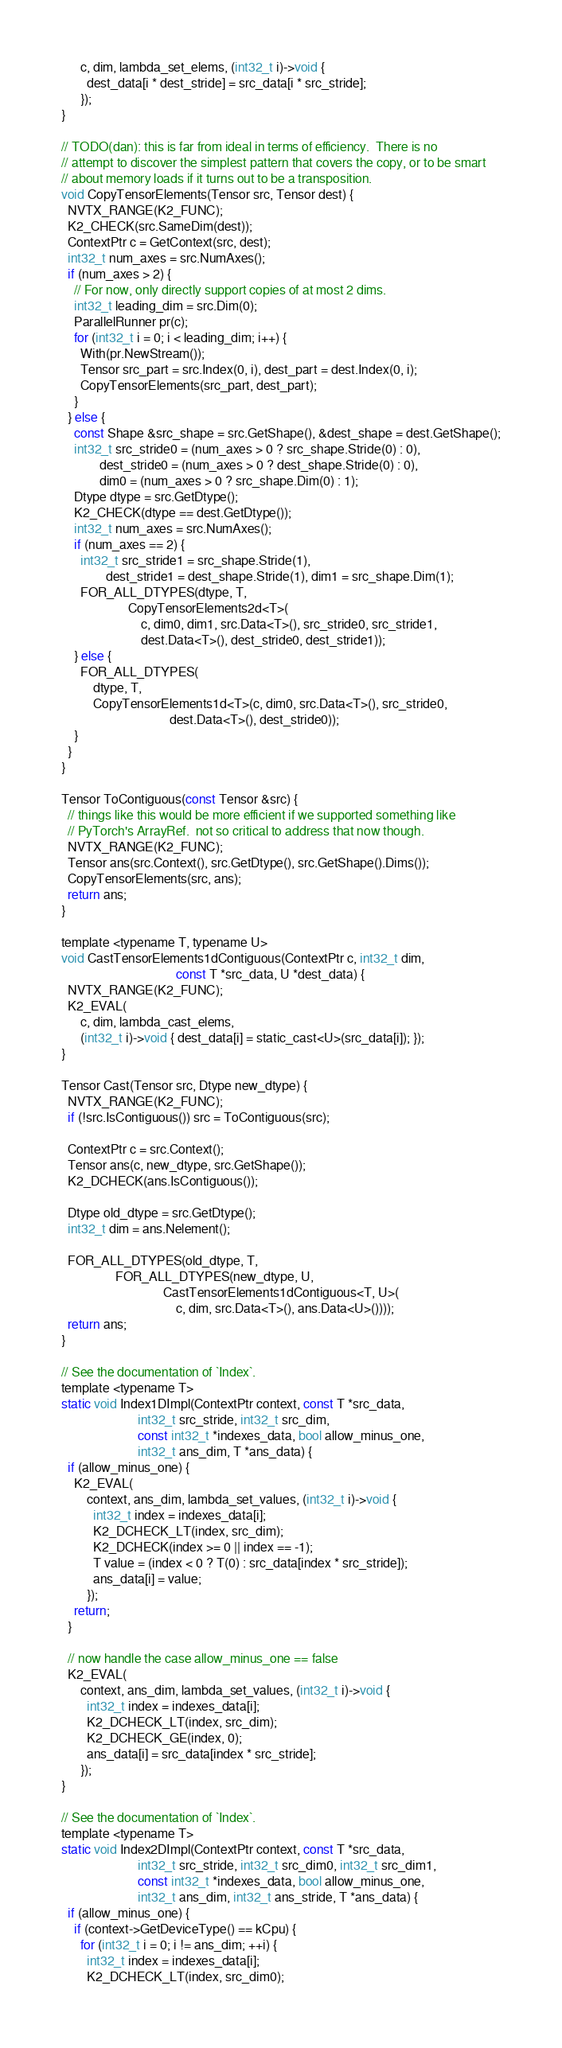Convert code to text. <code><loc_0><loc_0><loc_500><loc_500><_Cuda_>      c, dim, lambda_set_elems, (int32_t i)->void {
        dest_data[i * dest_stride] = src_data[i * src_stride];
      });
}

// TODO(dan): this is far from ideal in terms of efficiency.  There is no
// attempt to discover the simplest pattern that covers the copy, or to be smart
// about memory loads if it turns out to be a transposition.
void CopyTensorElements(Tensor src, Tensor dest) {
  NVTX_RANGE(K2_FUNC);
  K2_CHECK(src.SameDim(dest));
  ContextPtr c = GetContext(src, dest);
  int32_t num_axes = src.NumAxes();
  if (num_axes > 2) {
    // For now, only directly support copies of at most 2 dims.
    int32_t leading_dim = src.Dim(0);
    ParallelRunner pr(c);
    for (int32_t i = 0; i < leading_dim; i++) {
      With(pr.NewStream());
      Tensor src_part = src.Index(0, i), dest_part = dest.Index(0, i);
      CopyTensorElements(src_part, dest_part);
    }
  } else {
    const Shape &src_shape = src.GetShape(), &dest_shape = dest.GetShape();
    int32_t src_stride0 = (num_axes > 0 ? src_shape.Stride(0) : 0),
            dest_stride0 = (num_axes > 0 ? dest_shape.Stride(0) : 0),
            dim0 = (num_axes > 0 ? src_shape.Dim(0) : 1);
    Dtype dtype = src.GetDtype();
    K2_CHECK(dtype == dest.GetDtype());
    int32_t num_axes = src.NumAxes();
    if (num_axes == 2) {
      int32_t src_stride1 = src_shape.Stride(1),
              dest_stride1 = dest_shape.Stride(1), dim1 = src_shape.Dim(1);
      FOR_ALL_DTYPES(dtype, T,
                     CopyTensorElements2d<T>(
                         c, dim0, dim1, src.Data<T>(), src_stride0, src_stride1,
                         dest.Data<T>(), dest_stride0, dest_stride1));
    } else {
      FOR_ALL_DTYPES(
          dtype, T,
          CopyTensorElements1d<T>(c, dim0, src.Data<T>(), src_stride0,
                                  dest.Data<T>(), dest_stride0));
    }
  }
}

Tensor ToContiguous(const Tensor &src) {
  // things like this would be more efficient if we supported something like
  // PyTorch's ArrayRef.  not so critical to address that now though.
  NVTX_RANGE(K2_FUNC);
  Tensor ans(src.Context(), src.GetDtype(), src.GetShape().Dims());
  CopyTensorElements(src, ans);
  return ans;
}

template <typename T, typename U>
void CastTensorElements1dContiguous(ContextPtr c, int32_t dim,
                                    const T *src_data, U *dest_data) {
  NVTX_RANGE(K2_FUNC);
  K2_EVAL(
      c, dim, lambda_cast_elems,
      (int32_t i)->void { dest_data[i] = static_cast<U>(src_data[i]); });
}

Tensor Cast(Tensor src, Dtype new_dtype) {
  NVTX_RANGE(K2_FUNC);
  if (!src.IsContiguous()) src = ToContiguous(src);

  ContextPtr c = src.Context();
  Tensor ans(c, new_dtype, src.GetShape());
  K2_DCHECK(ans.IsContiguous());

  Dtype old_dtype = src.GetDtype();
  int32_t dim = ans.Nelement();

  FOR_ALL_DTYPES(old_dtype, T,
                 FOR_ALL_DTYPES(new_dtype, U,
                                CastTensorElements1dContiguous<T, U>(
                                    c, dim, src.Data<T>(), ans.Data<U>())));
  return ans;
}

// See the documentation of `Index`.
template <typename T>
static void Index1DImpl(ContextPtr context, const T *src_data,
                        int32_t src_stride, int32_t src_dim,
                        const int32_t *indexes_data, bool allow_minus_one,
                        int32_t ans_dim, T *ans_data) {
  if (allow_minus_one) {
    K2_EVAL(
        context, ans_dim, lambda_set_values, (int32_t i)->void {
          int32_t index = indexes_data[i];
          K2_DCHECK_LT(index, src_dim);
          K2_DCHECK(index >= 0 || index == -1);
          T value = (index < 0 ? T(0) : src_data[index * src_stride]);
          ans_data[i] = value;
        });
    return;
  }

  // now handle the case allow_minus_one == false
  K2_EVAL(
      context, ans_dim, lambda_set_values, (int32_t i)->void {
        int32_t index = indexes_data[i];
        K2_DCHECK_LT(index, src_dim);
        K2_DCHECK_GE(index, 0);
        ans_data[i] = src_data[index * src_stride];
      });
}

// See the documentation of `Index`.
template <typename T>
static void Index2DImpl(ContextPtr context, const T *src_data,
                        int32_t src_stride, int32_t src_dim0, int32_t src_dim1,
                        const int32_t *indexes_data, bool allow_minus_one,
                        int32_t ans_dim, int32_t ans_stride, T *ans_data) {
  if (allow_minus_one) {
    if (context->GetDeviceType() == kCpu) {
      for (int32_t i = 0; i != ans_dim; ++i) {
        int32_t index = indexes_data[i];
        K2_DCHECK_LT(index, src_dim0);</code> 